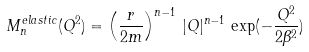Convert formula to latex. <formula><loc_0><loc_0><loc_500><loc_500>M _ { n } ^ { e l a s t i c } ( Q ^ { 2 } ) = \left ( \frac { r } { 2 m } \right ) ^ { n - 1 } \, | Q | ^ { n - 1 } \, \exp ( - \frac { Q ^ { 2 } } { 2 \beta ^ { 2 } } )</formula> 